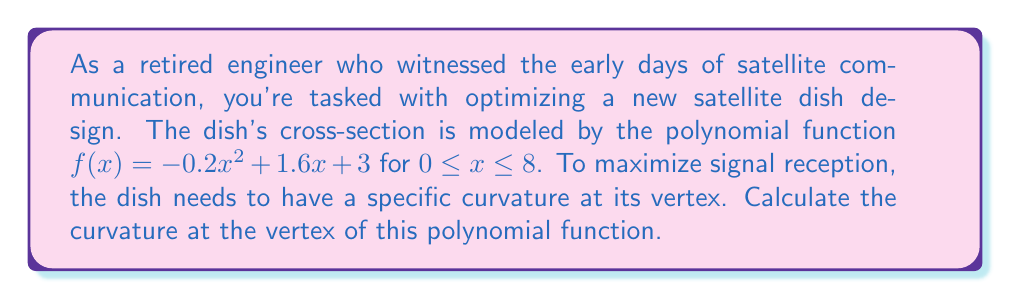Solve this math problem. Let's approach this step-by-step:

1) The curvature of a polynomial function at any point is given by the formula:

   $$K = \frac{|f''(x)|}{(1 + (f'(x))^2)^{3/2}}$$

   where $f'(x)$ is the first derivative and $f''(x)$ is the second derivative.

2) For a quadratic function $f(x) = ax^2 + bx + c$, the vertex occurs at $x = -\frac{b}{2a}$.

3) In our case, $a = -0.2$, $b = 1.6$, and $c = 3$. So the x-coordinate of the vertex is:

   $$x = -\frac{1.6}{2(-0.2)} = 4$$

4) Now, let's find $f'(x)$ and $f''(x)$:

   $f'(x) = -0.4x + 1.6$
   $f''(x) = -0.4$

5) At the vertex $(x = 4)$:

   $f'(4) = -0.4(4) + 1.6 = 0$
   $f''(4) = -0.4$

6) Plugging these into the curvature formula:

   $$K = \frac{|-0.4|}{(1 + (0)^2)^{3/2}} = 0.4$$

Therefore, the curvature at the vertex of the satellite dish is 0.4.
Answer: 0.4 